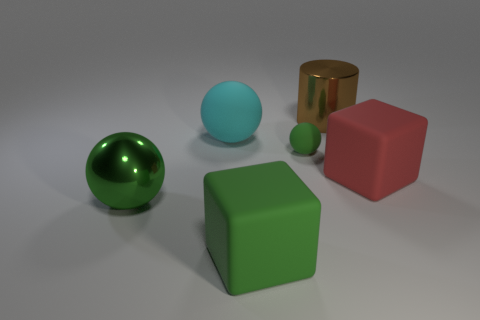Do the small matte thing and the big metallic cylinder have the same color?
Your answer should be very brief. No. The big block that is behind the large sphere in front of the large cyan ball is made of what material?
Provide a succinct answer. Rubber. There is a large red object that is the same shape as the large green matte object; what is it made of?
Offer a terse response. Rubber. There is a sphere in front of the sphere that is on the right side of the large matte sphere; are there any metal spheres right of it?
Give a very brief answer. No. What number of other objects are the same color as the big matte ball?
Ensure brevity in your answer.  0. What number of things are behind the tiny green rubber thing and to the left of the small green ball?
Make the answer very short. 1. What shape is the tiny matte object?
Provide a succinct answer. Sphere. What number of other things are made of the same material as the big brown thing?
Provide a succinct answer. 1. The metallic sphere that is on the left side of the large red matte object in front of the large shiny object right of the small green rubber ball is what color?
Your response must be concise. Green. What material is the brown cylinder that is the same size as the red block?
Ensure brevity in your answer.  Metal. 